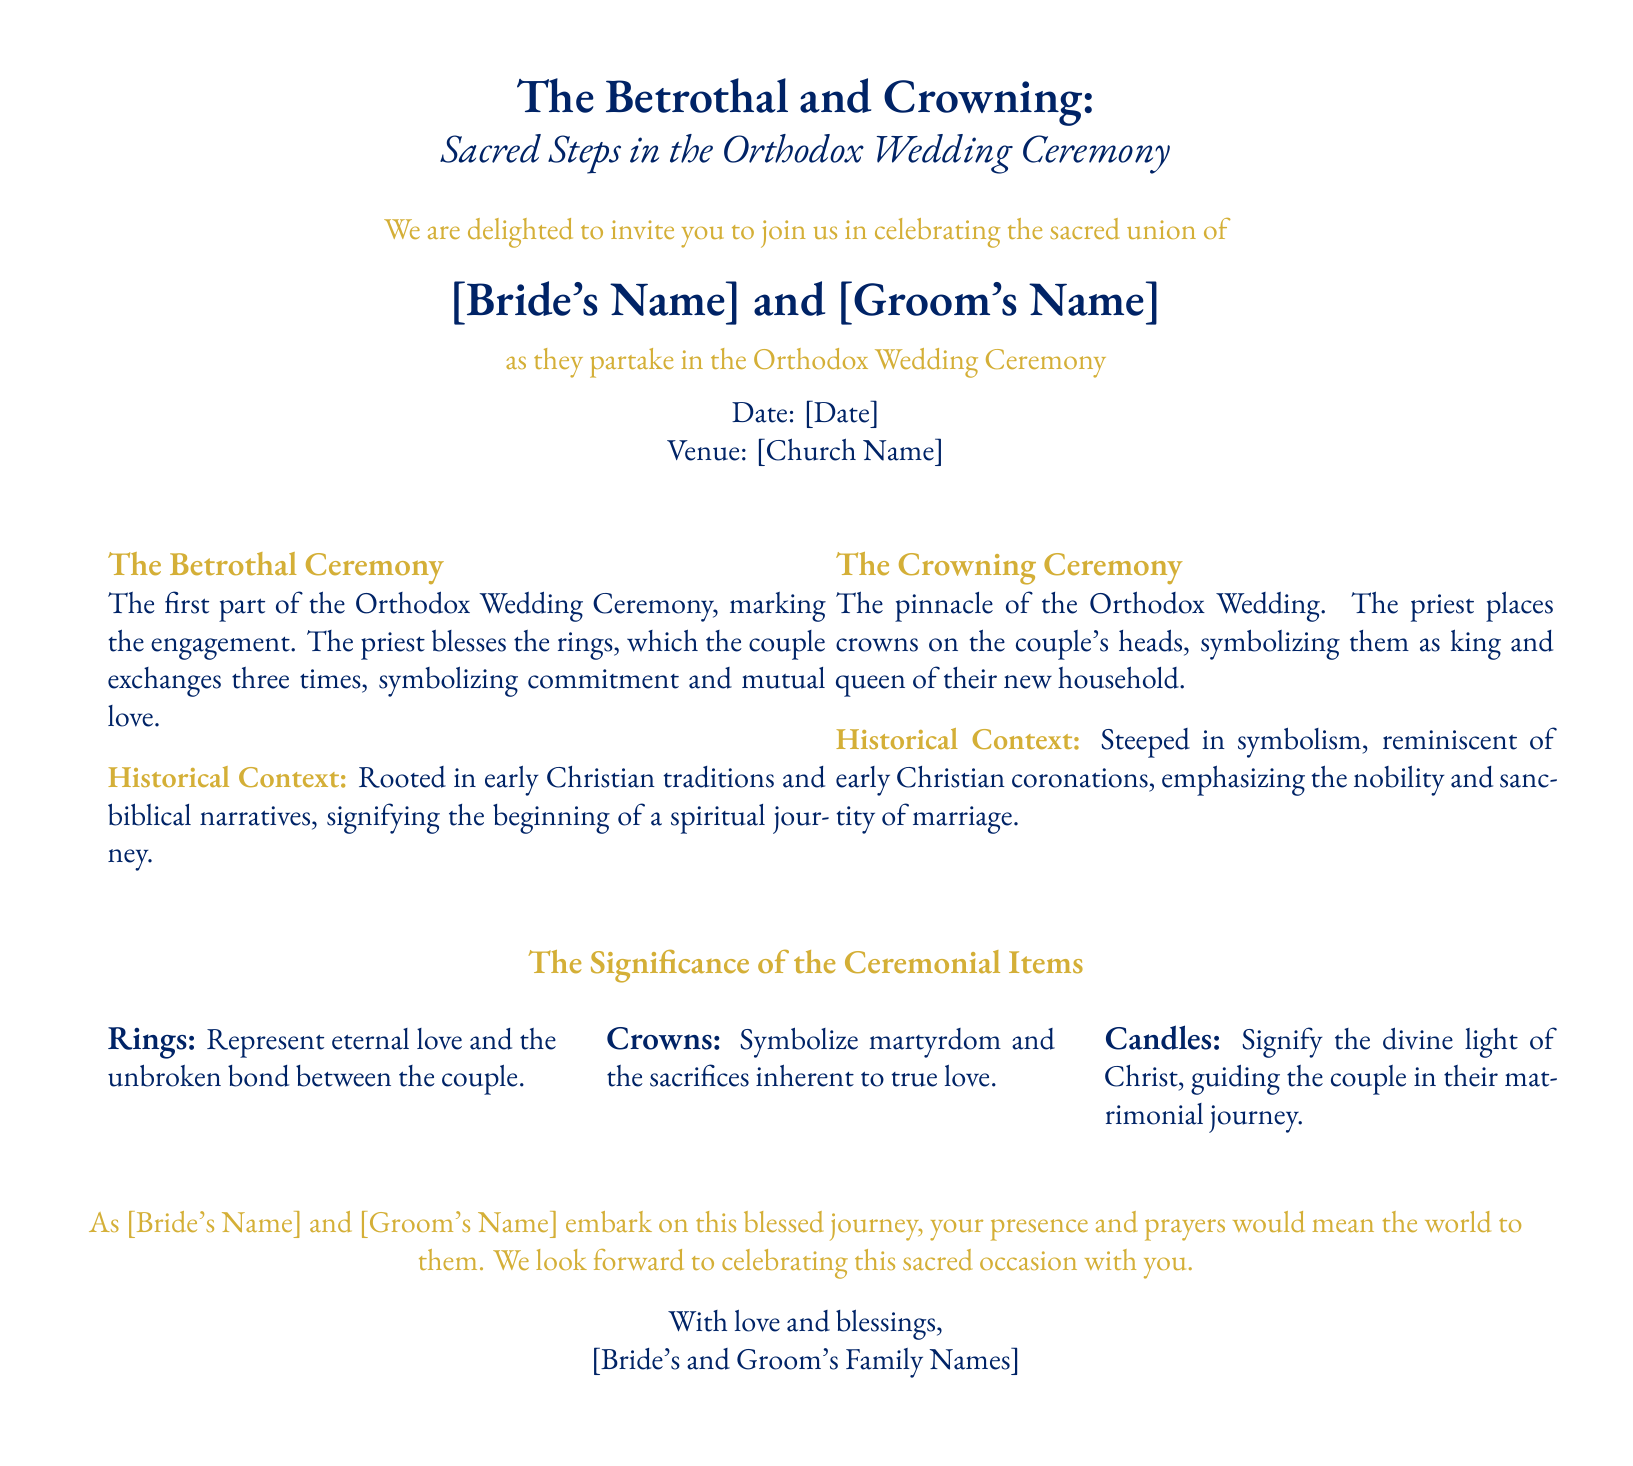What are the names of the couple? The names of the couple are mentioned at the beginning of the invitation, formatted as [Bride's Name] and [Groom's Name].
Answer: [Bride's Name] and [Groom's Name] What is the purpose of the rings in the ceremony? The document states that rings represent eternal love and the unbroken bond between the couple.
Answer: Eternal love and the unbroken bond What date is the wedding scheduled for? The date of the wedding is indicated in the invitation as [Date].
Answer: [Date] What do the crowns symbolize in the ceremony? According to the document, crowns symbolize martyrdom and the sacrifices inherent to true love.
Answer: Martyrdom and sacrifices What does the document invite attendees to do? The invitation expresses a desire for people's presence and prayers as the couple embarks on their journey.
Answer: Attend and pray How many times do the couple exchange rings during the Betrothal ceremony? The text states that the couple exchanges the rings three times during the ceremony.
Answer: Three times What is the primary color used in the invitation? The invitation prominently features deep blue as a central color, especially in the text.
Answer: Deep blue What is indicated as the venue for the wedding? The venue is specified in the document as [Church Name].
Answer: [Church Name] How are the items of the ceremony, such as candles, described in terms of significance? The candles signify the divine light of Christ, guiding the couple in their matrimonial journey.
Answer: Divine light of Christ 